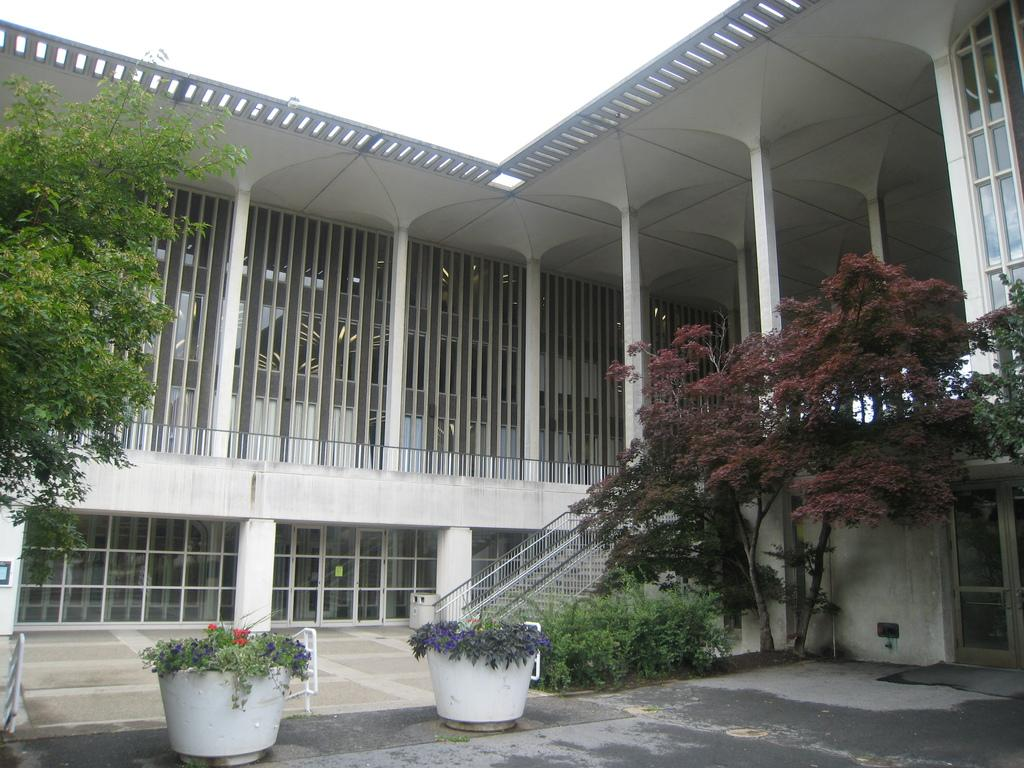What type of structure is present in the image? There is a building in the image. What features can be observed on the building? The building has stairs, windows, pillars, and a door. What is located in front of the building? There are trees and potted plants in front of the building. What is visible at the top of the image? The sky is visible at the top of the image. Can you tell me how many lawyers are standing next to the building in the image? There is no mention of lawyers in the image, so we cannot determine their presence or number. What is the wish of the person standing in front of the building in the image? There is no person visible in the image, and therefore no wish can be attributed to them. 